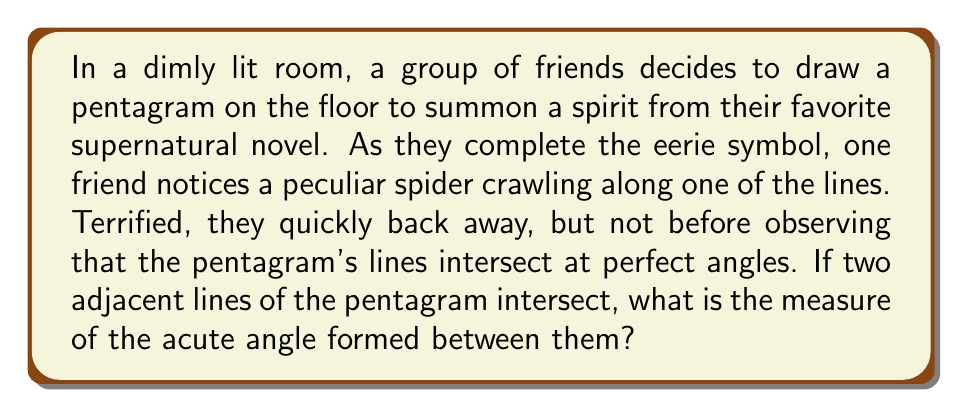Help me with this question. Let's approach this step-by-step:

1) A regular pentagram is formed by extending the edges of a regular pentagon until they intersect.

2) In a regular pentagon, each interior angle measures:
   $$\frac{(5-2) \times 180°}{5} = 108°$$

3) The pentagram is made up of five isosceles triangles. Let's focus on one of these triangles.

4) In this isosceles triangle:
   - The apex angle (at the center of the pentagram) is $36°$ (because $360° \div 5 = 72°$, and $72° \div 2 = 36°$)
   - The two base angles are equal. Let's call each of these angles $x$.

5) The sum of angles in a triangle is $180°$, so:
   $$36° + x + x = 180°$$
   $$36° + 2x = 180°$$
   $$2x = 144°$$
   $$x = 72°$$

6) The angle we're looking for is the supplement of $x$:
   $$180° - 72° = 108°$$

7) However, this is the obtuse angle. The question asks for the acute angle, which is:
   $$180° - 108° = 72°$$

[asy]
unitsize(50);
pair A=(0,0), B=(1,0), C=(-cos(72*pi/180),sin(72*pi/180)), D=(cos(72*pi/180),sin(72*pi/180)), E=(0,1);
draw(A--B--C--D--E--cycle);
draw(A--C, A--D, B--D, B--E, C--E);
label("72°", (0.2,0.2), NE);
[/asy]
Answer: The measure of the acute angle formed between two intersecting lines of the pentagram is $72°$. 